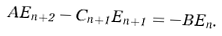Convert formula to latex. <formula><loc_0><loc_0><loc_500><loc_500>A { E } _ { n + 2 } - C _ { n + 1 } { E } _ { n + 1 } = - B { E } _ { n } .</formula> 